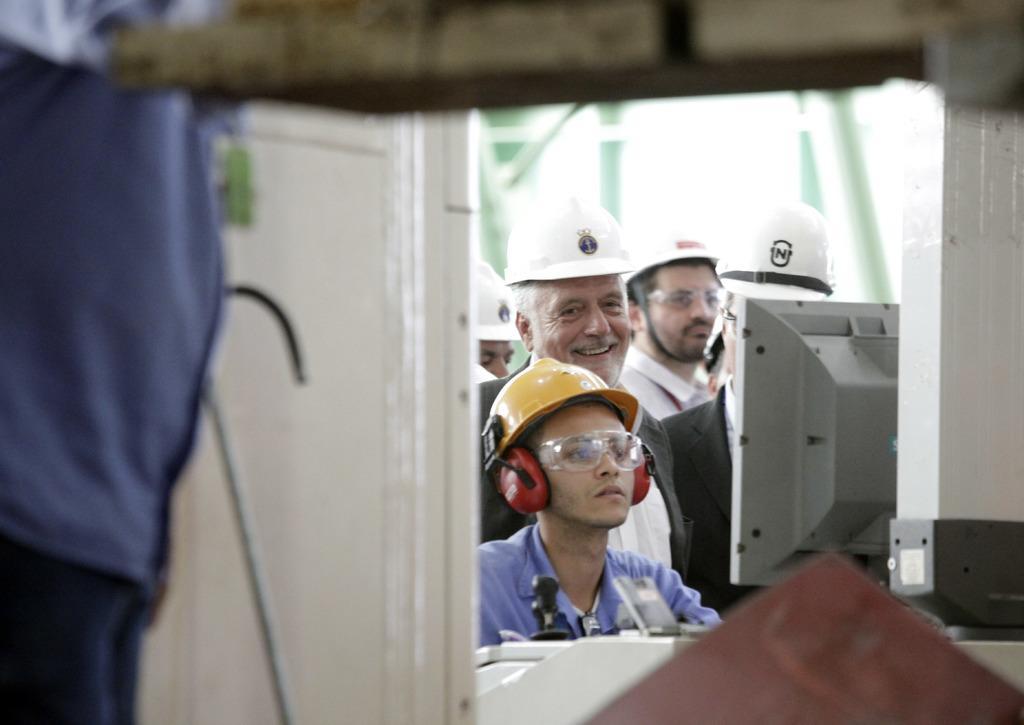Please provide a concise description of this image. In this image, we can see some people. We can also see a device and some objects. We can also see the door and a black colored object. We can also see an object at the bottom. 